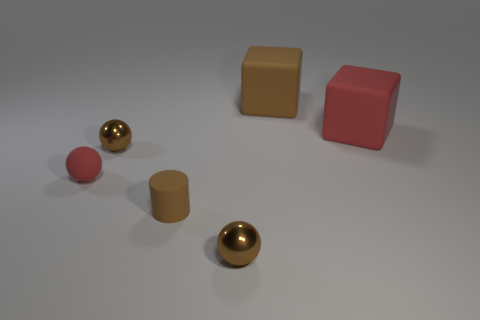Add 2 big red matte cubes. How many objects exist? 8 Subtract all cylinders. How many objects are left? 5 Add 4 large rubber cubes. How many large rubber cubes are left? 6 Add 1 big brown matte cubes. How many big brown matte cubes exist? 2 Subtract 0 blue balls. How many objects are left? 6 Subtract all large objects. Subtract all big red cubes. How many objects are left? 3 